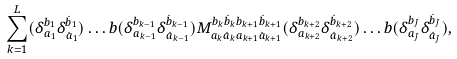Convert formula to latex. <formula><loc_0><loc_0><loc_500><loc_500>\sum _ { k = 1 } ^ { L } ( \delta _ { a _ { 1 } } ^ { b _ { 1 } } \delta _ { \dot { a } _ { 1 } } ^ { \dot { b } _ { 1 } } ) \dots b ( \delta _ { a _ { k - 1 } } ^ { b _ { k - 1 } } \delta _ { \dot { a } _ { k - 1 } } ^ { \dot { b } _ { k - 1 } } ) M _ { a _ { k } \dot { a } _ { k } a _ { k + 1 } \dot { a } _ { k + 1 } } ^ { b _ { k } \dot { b } _ { k } b _ { k + 1 } \dot { b } _ { k + 1 } } ( \delta _ { a _ { k + 2 } } ^ { b _ { k + 2 } } \delta _ { \dot { a } _ { k + 2 } } ^ { \dot { b } _ { k + 2 } } ) \dots b ( \delta _ { a _ { J } } ^ { b _ { J } } \delta _ { \dot { a } _ { J } } ^ { \dot { b } _ { J } } ) ,</formula> 